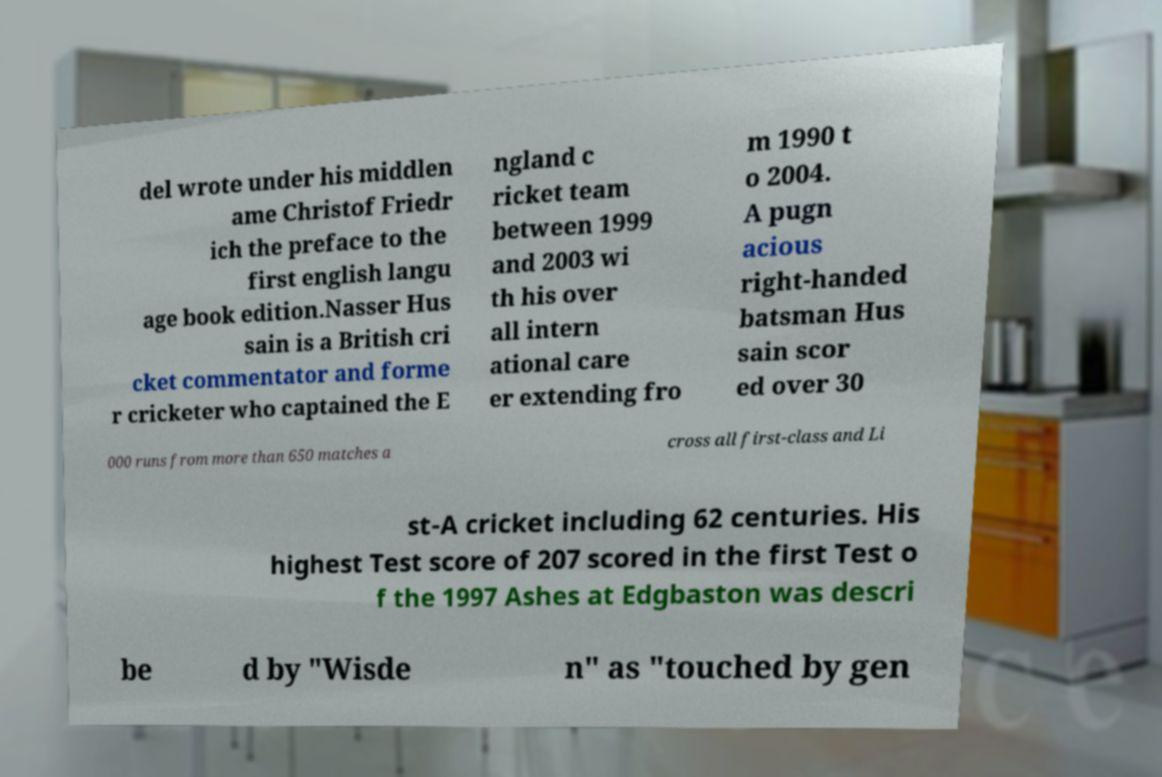Can you read and provide the text displayed in the image?This photo seems to have some interesting text. Can you extract and type it out for me? del wrote under his middlen ame Christof Friedr ich the preface to the first english langu age book edition.Nasser Hus sain is a British cri cket commentator and forme r cricketer who captained the E ngland c ricket team between 1999 and 2003 wi th his over all intern ational care er extending fro m 1990 t o 2004. A pugn acious right-handed batsman Hus sain scor ed over 30 000 runs from more than 650 matches a cross all first-class and Li st-A cricket including 62 centuries. His highest Test score of 207 scored in the first Test o f the 1997 Ashes at Edgbaston was descri be d by "Wisde n" as "touched by gen 